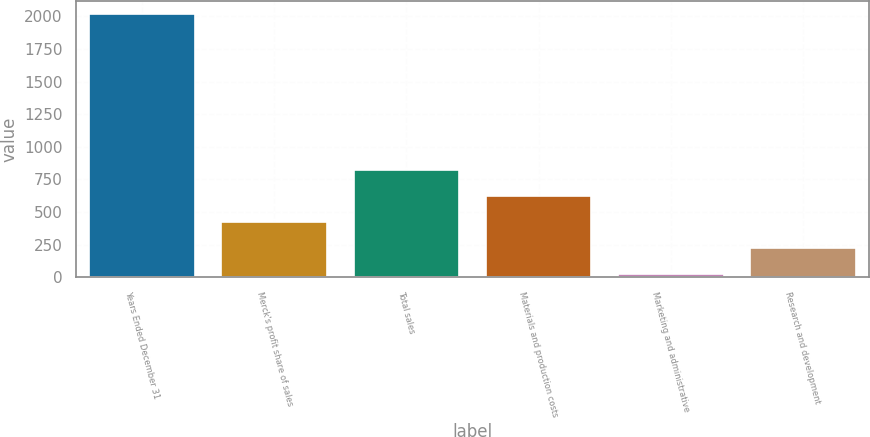<chart> <loc_0><loc_0><loc_500><loc_500><bar_chart><fcel>Years Ended December 31<fcel>Merck's profit share of sales<fcel>Total sales<fcel>Materials and production costs<fcel>Marketing and administrative<fcel>Research and development<nl><fcel>2016<fcel>424<fcel>822<fcel>623<fcel>26<fcel>225<nl></chart> 